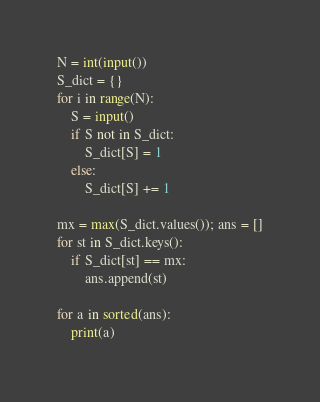Convert code to text. <code><loc_0><loc_0><loc_500><loc_500><_Python_>N = int(input())
S_dict = {}
for i in range(N):
    S = input()
    if S not in S_dict:
        S_dict[S] = 1
    else:
        S_dict[S] += 1

mx = max(S_dict.values()); ans = []
for st in S_dict.keys():
    if S_dict[st] == mx:
        ans.append(st)

for a in sorted(ans):
    print(a)</code> 